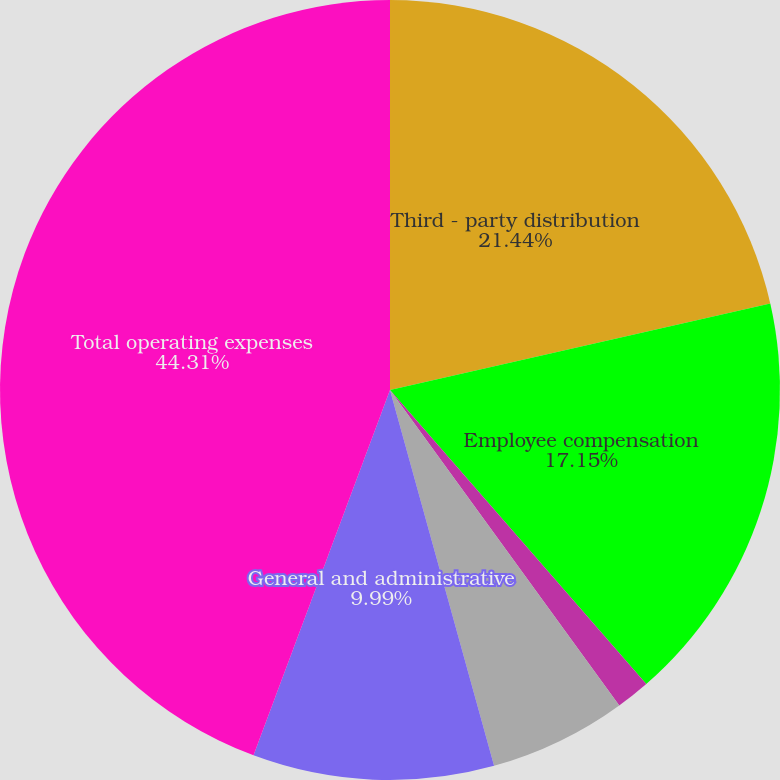Convert chart to OTSL. <chart><loc_0><loc_0><loc_500><loc_500><pie_chart><fcel>Third - party distribution<fcel>Employee compensation<fcel>Marketing<fcel>Property office and technology<fcel>General and administrative<fcel>Total operating expenses<nl><fcel>21.44%<fcel>17.15%<fcel>1.41%<fcel>5.7%<fcel>9.99%<fcel>44.31%<nl></chart> 